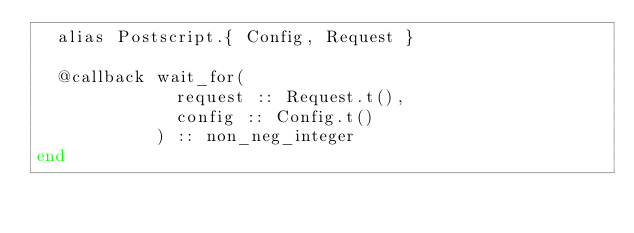<code> <loc_0><loc_0><loc_500><loc_500><_Elixir_>  alias Postscript.{ Config, Request }

  @callback wait_for(
              request :: Request.t(),
              config :: Config.t()
            ) :: non_neg_integer
end
</code> 